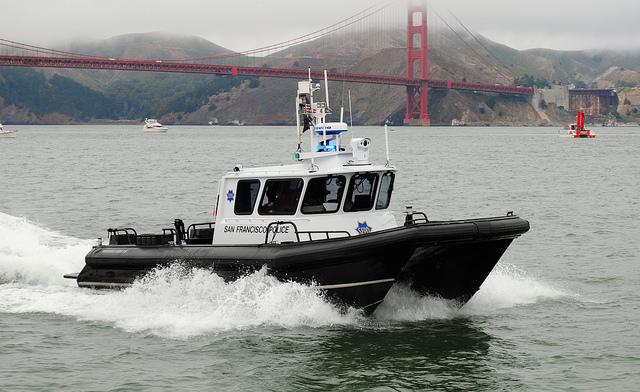What color is the body of this police boat? Please explain your reasoning. black. It's the opposite of the white top 